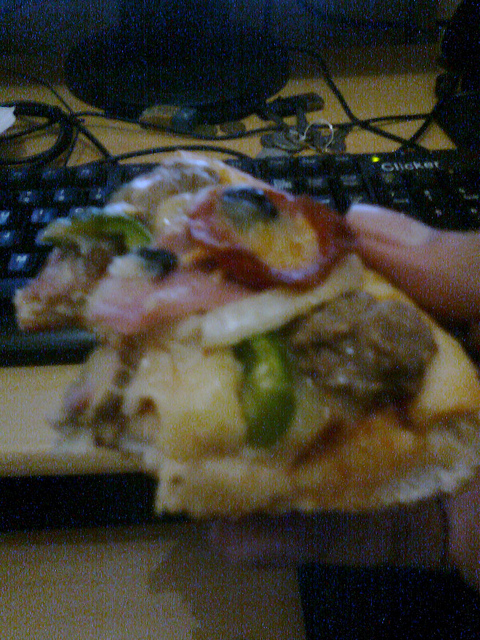Is this a toast? No, this is a slice of pizza, not toast. 